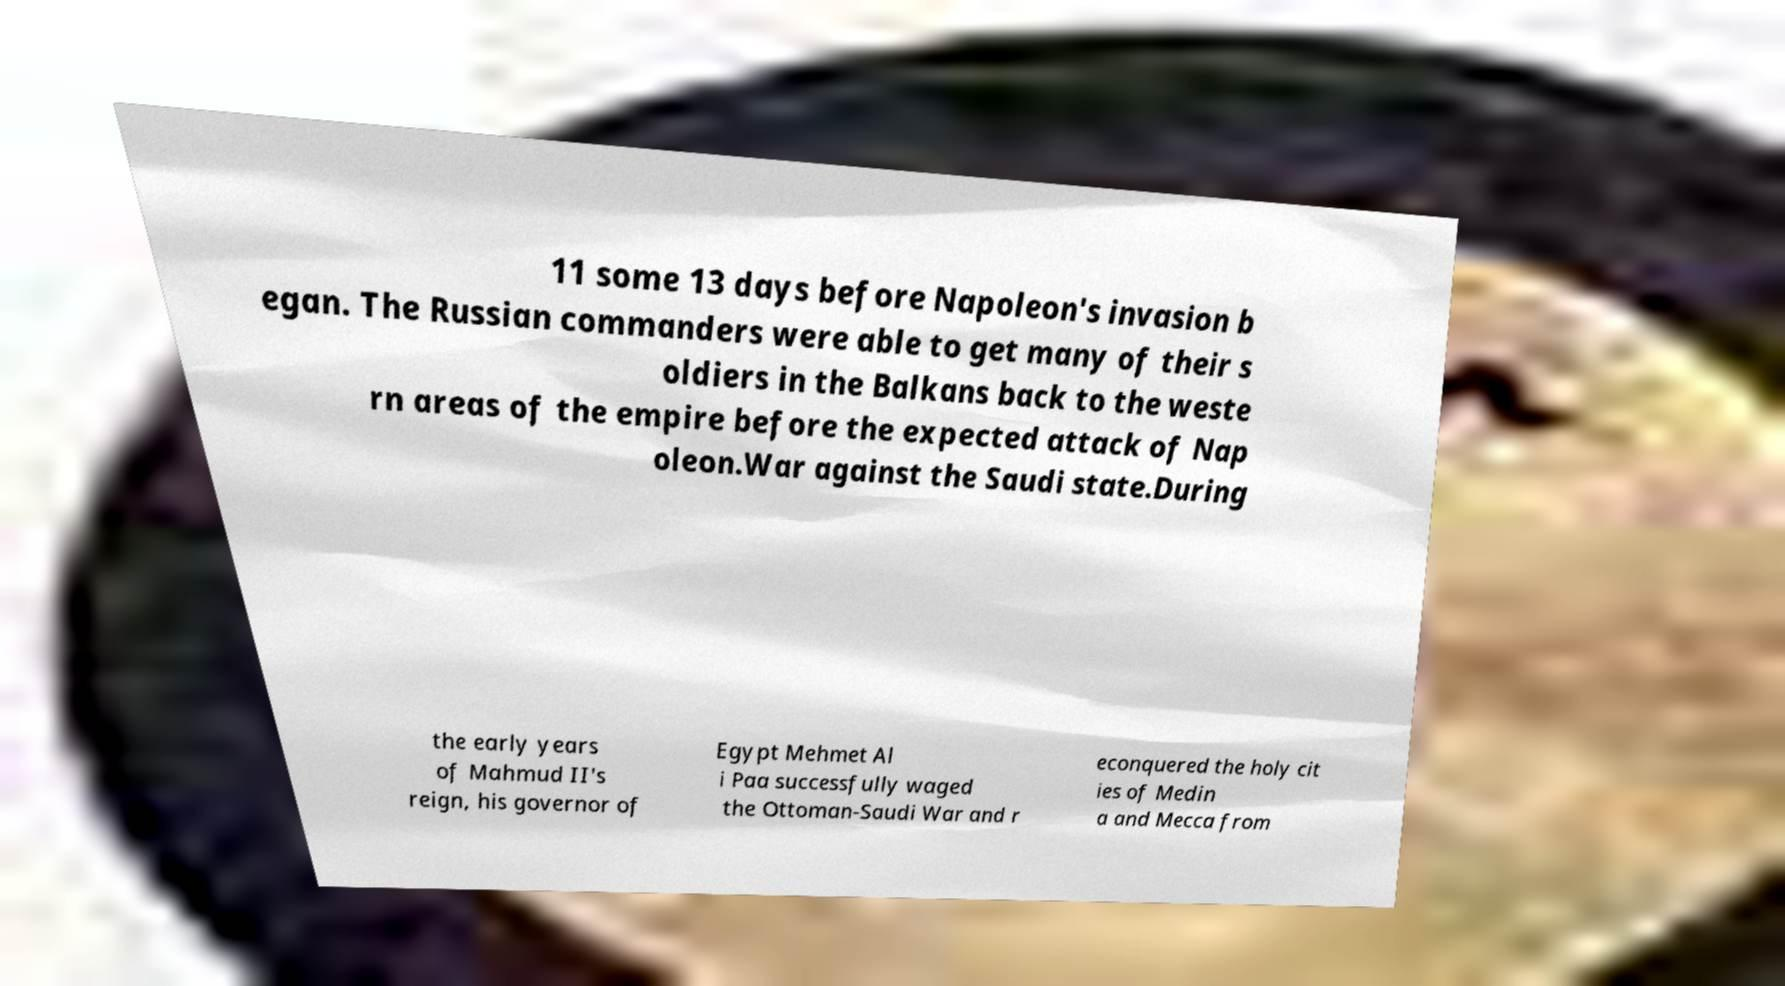Could you extract and type out the text from this image? 11 some 13 days before Napoleon's invasion b egan. The Russian commanders were able to get many of their s oldiers in the Balkans back to the weste rn areas of the empire before the expected attack of Nap oleon.War against the Saudi state.During the early years of Mahmud II's reign, his governor of Egypt Mehmet Al i Paa successfully waged the Ottoman-Saudi War and r econquered the holy cit ies of Medin a and Mecca from 